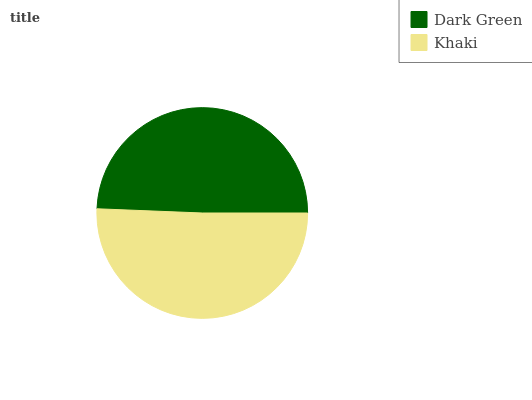Is Dark Green the minimum?
Answer yes or no. Yes. Is Khaki the maximum?
Answer yes or no. Yes. Is Khaki the minimum?
Answer yes or no. No. Is Khaki greater than Dark Green?
Answer yes or no. Yes. Is Dark Green less than Khaki?
Answer yes or no. Yes. Is Dark Green greater than Khaki?
Answer yes or no. No. Is Khaki less than Dark Green?
Answer yes or no. No. Is Khaki the high median?
Answer yes or no. Yes. Is Dark Green the low median?
Answer yes or no. Yes. Is Dark Green the high median?
Answer yes or no. No. Is Khaki the low median?
Answer yes or no. No. 